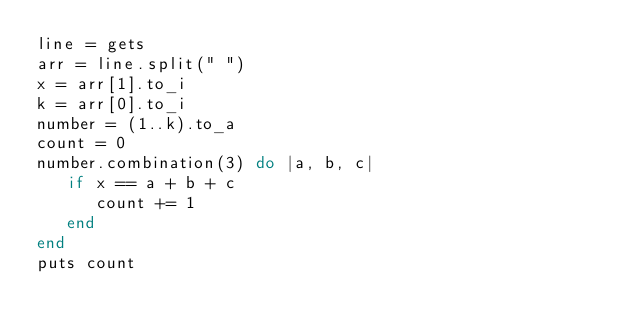Convert code to text. <code><loc_0><loc_0><loc_500><loc_500><_Ruby_>line = gets
arr = line.split(" ")
x = arr[1].to_i
k = arr[0].to_i
number = (1..k).to_a
count = 0
number.combination(3) do |a, b, c|
   if x == a + b + c
      count += 1
   end
end
puts count</code> 